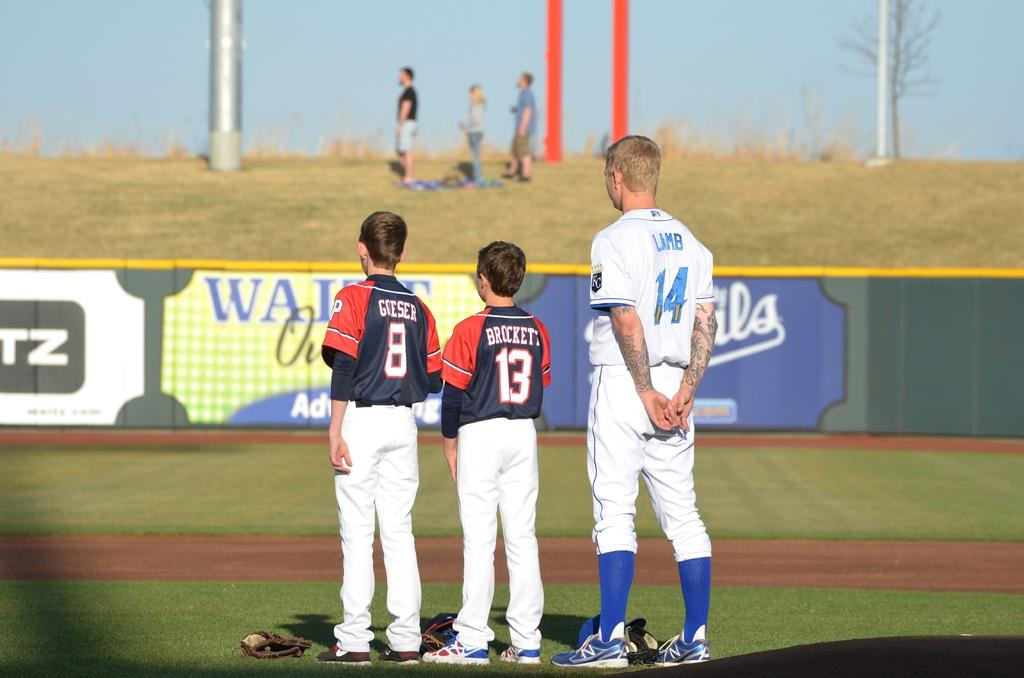<image>
Render a clear and concise summary of the photo. A man in a white uniform has the name Lamb on the back. 